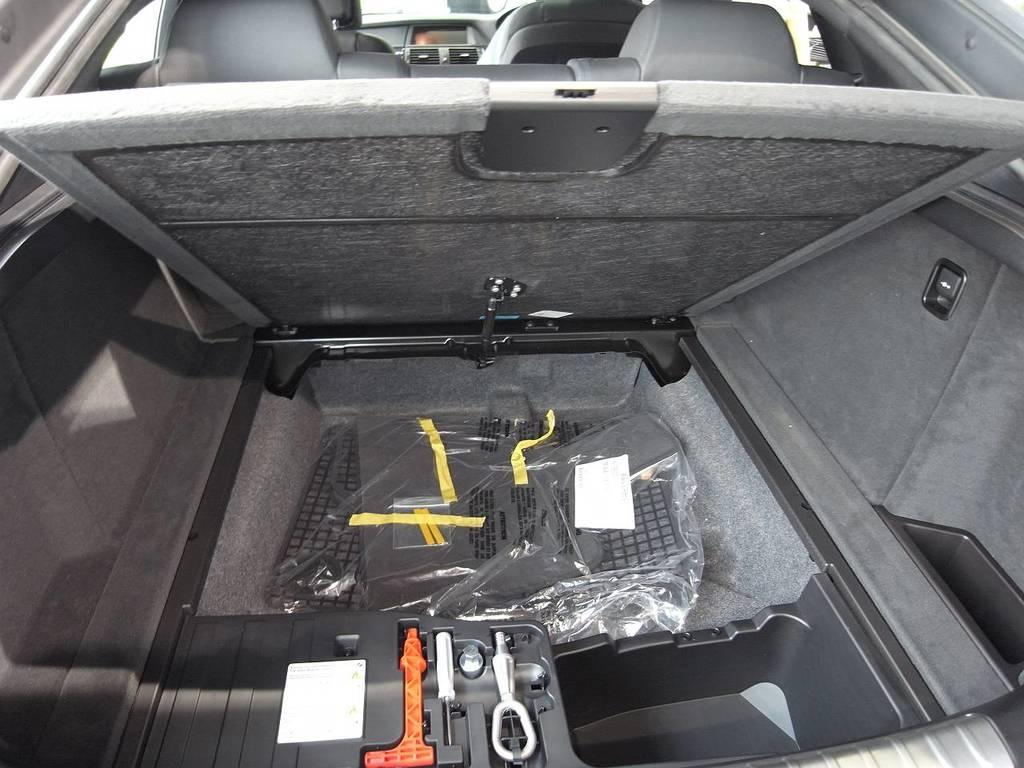What type of setting is depicted in the image? The image is an internal view of a car. What can be found inside the car? There are seats in the car. What is located in the boot of the car? There are tools in the boot of the car. What type of advice is the lawyer giving to the cattle in the image? There is no lawyer or cattle present in the image; it is an internal view of a car with seats and tools in the boot. 